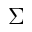<formula> <loc_0><loc_0><loc_500><loc_500>\Sigma</formula> 